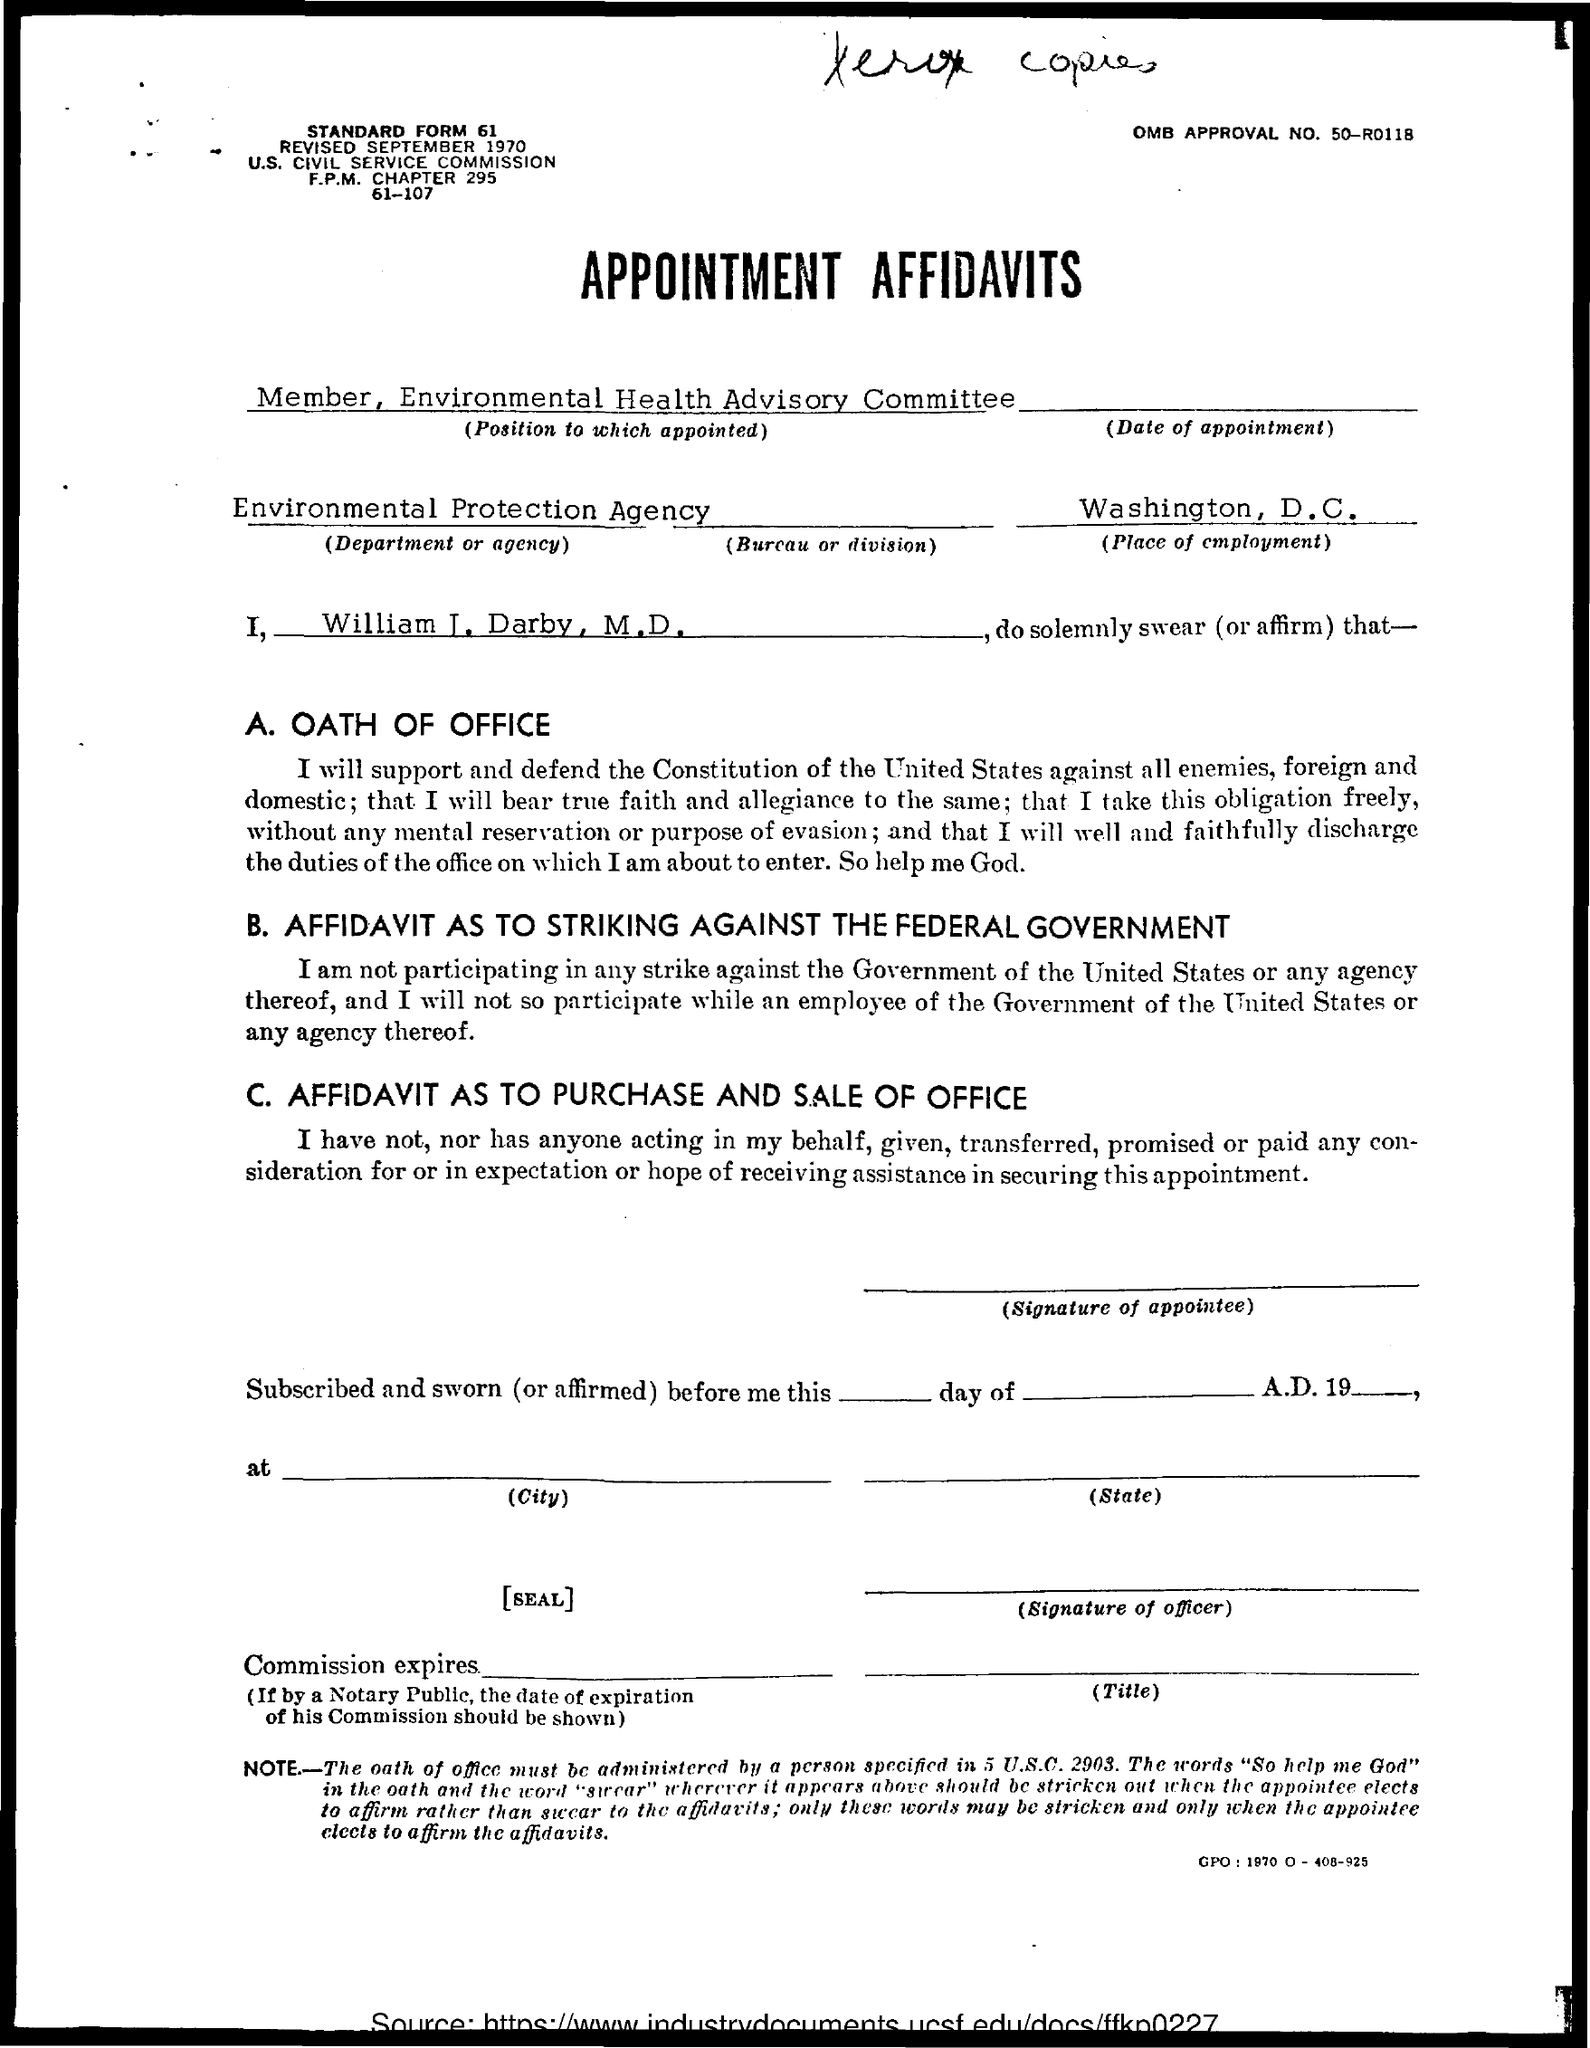Mention a couple of crucial points in this snapshot. The place of employment is Washington, D.C. The applicant's name is William J. Darby, M.D. 